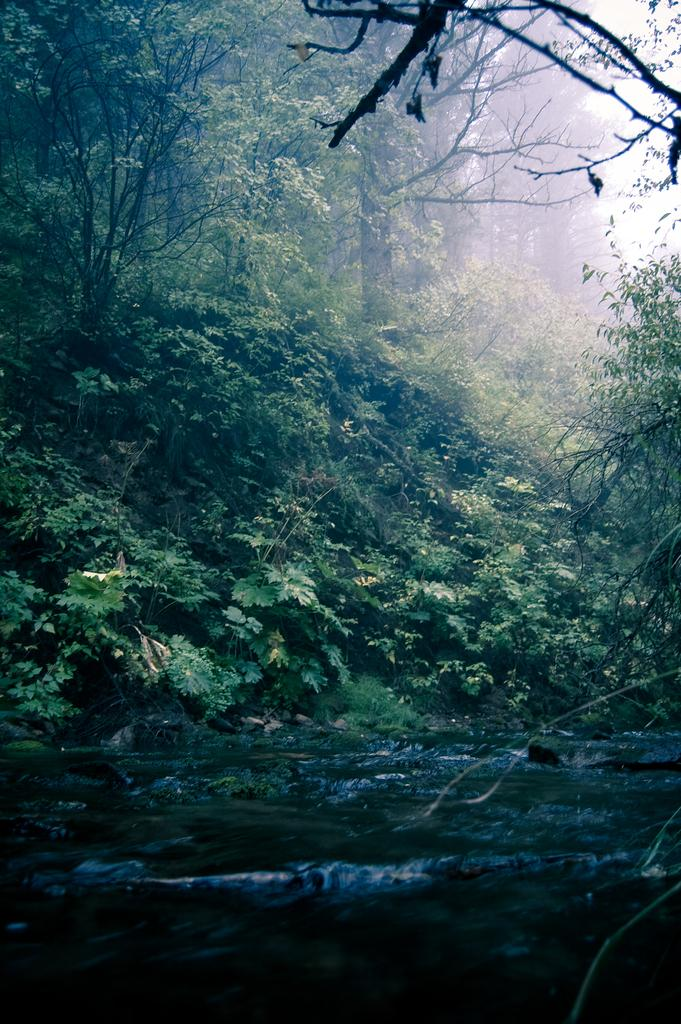What type of vegetation can be seen in the image? There are many trees, plants, and grass visible in the image. What is the condition of the water in the image? There is water flow visible at the bottom of the image. What part of the sky is visible in the image? The sky is visible in the top right of the image. What is the weather like in the background of the image? There is fog in the background of the image. What type of trade is happening between the trees in the image? There is no indication of any trade happening between the trees in the image. What is the temper of the plants in the image? The temper of the plants cannot be determined from the image. 